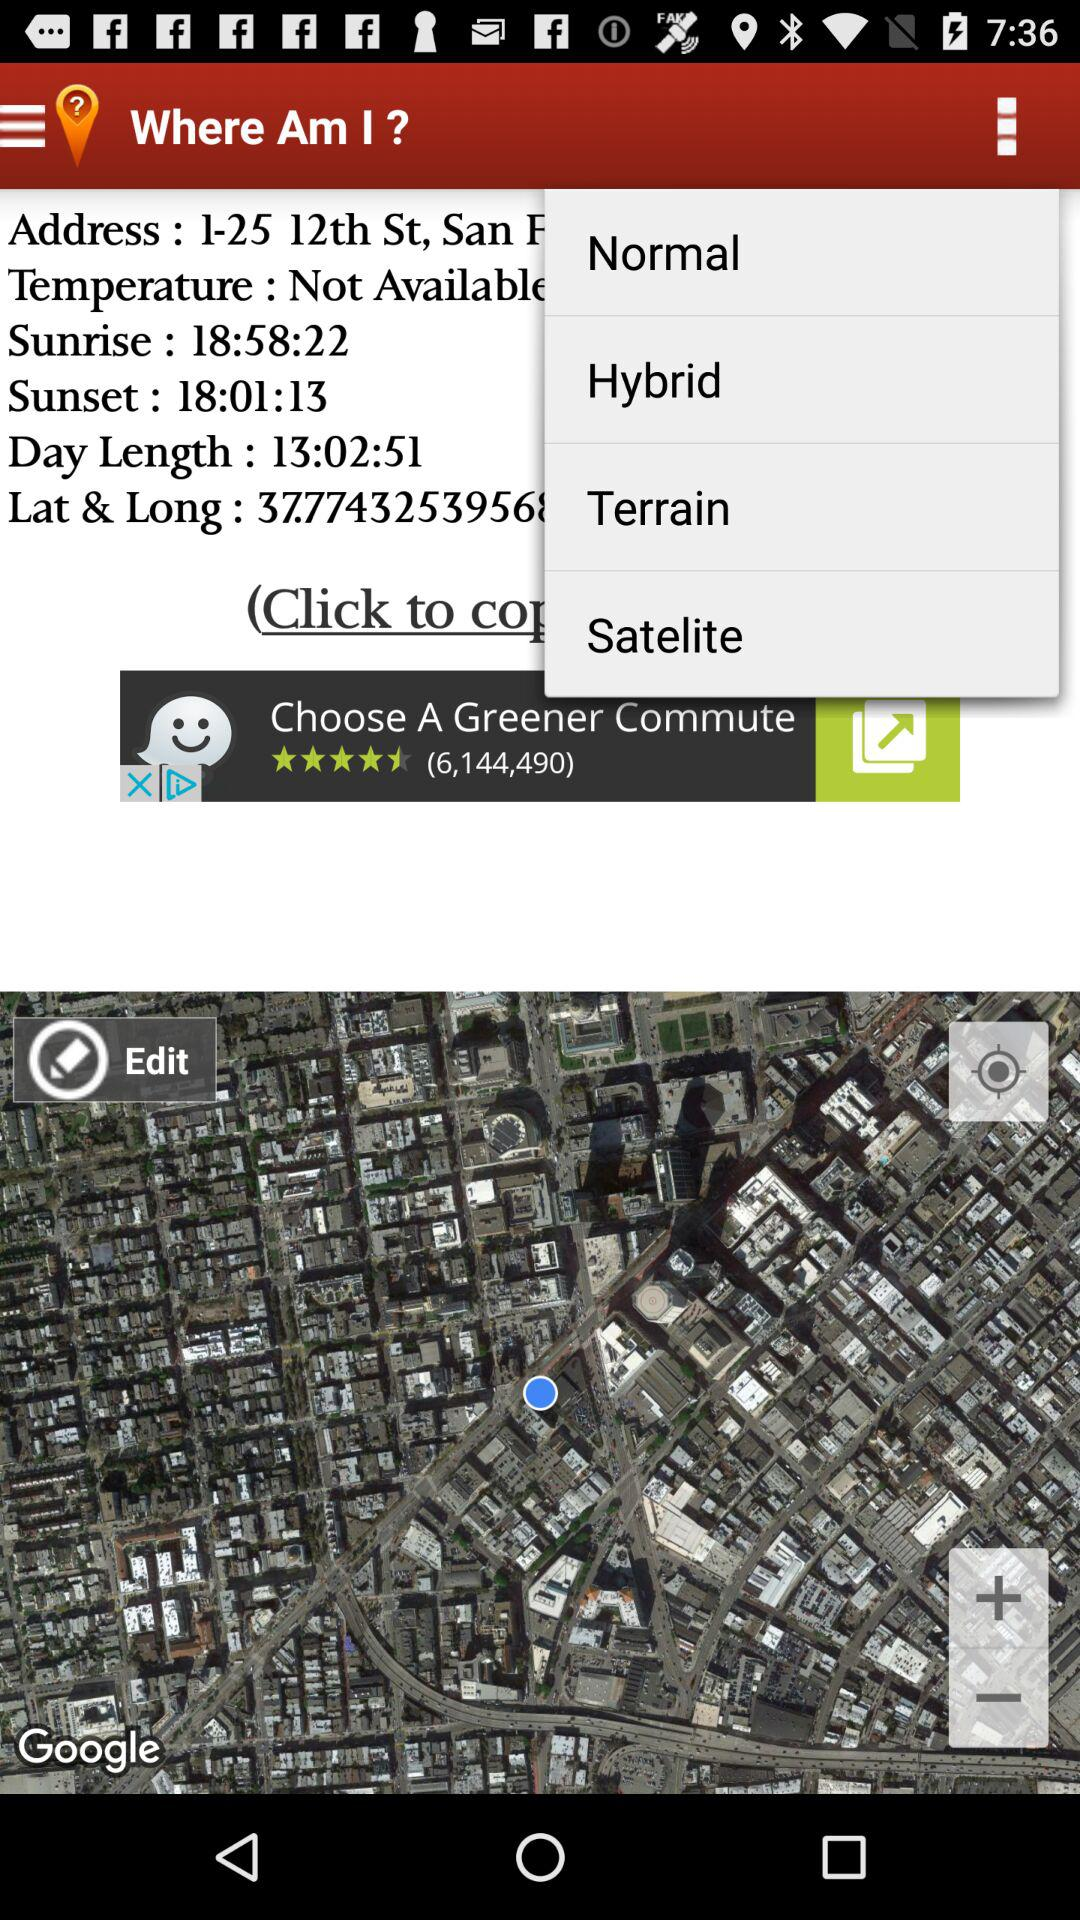What is the latitude and longitude?
When the provided information is insufficient, respond with <no answer>. <no answer> 